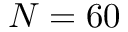<formula> <loc_0><loc_0><loc_500><loc_500>N = 6 0</formula> 